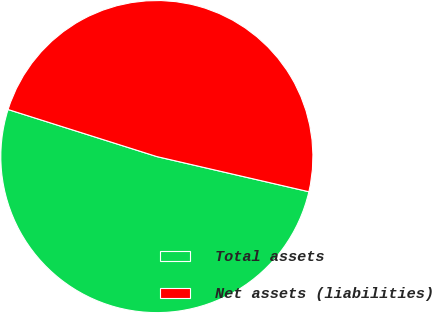Convert chart to OTSL. <chart><loc_0><loc_0><loc_500><loc_500><pie_chart><fcel>Total assets<fcel>Net assets (liabilities)<nl><fcel>51.26%<fcel>48.74%<nl></chart> 